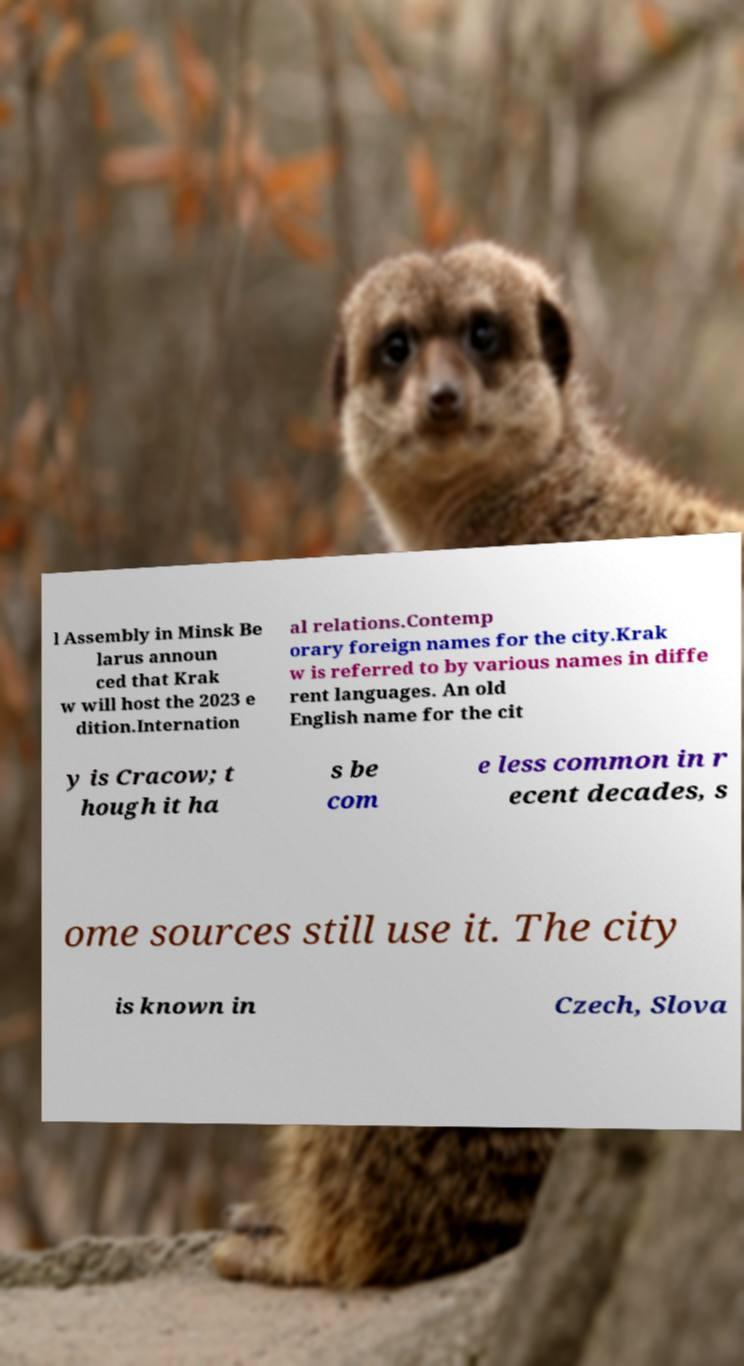I need the written content from this picture converted into text. Can you do that? l Assembly in Minsk Be larus announ ced that Krak w will host the 2023 e dition.Internation al relations.Contemp orary foreign names for the city.Krak w is referred to by various names in diffe rent languages. An old English name for the cit y is Cracow; t hough it ha s be com e less common in r ecent decades, s ome sources still use it. The city is known in Czech, Slova 